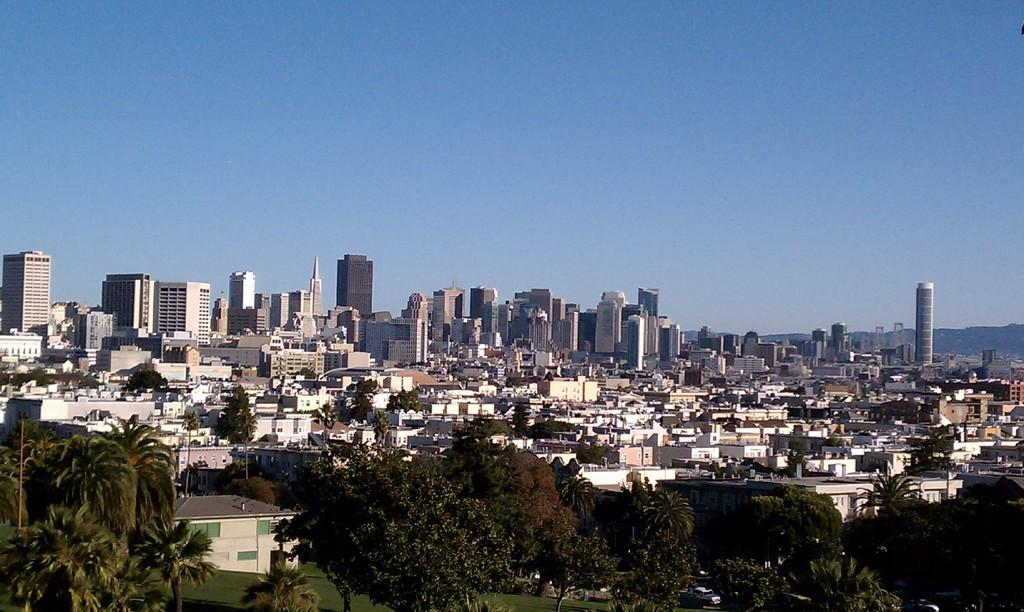What type of vegetation can be seen in the image? There are trees in the image. What type of structures are present in the image? There are buildings in the image. What covers the ground in the image? There is grass on the ground in the image. What can be seen in the background of the image? The sky is visible in the background of the image. What is the terrain feature in the image? There is a hill in the image. What type of hands can be seen holding a paste in the image? There are no hands or paste present in the image. Is there a flame visible in the image? No, there is no flame visible in the image. 